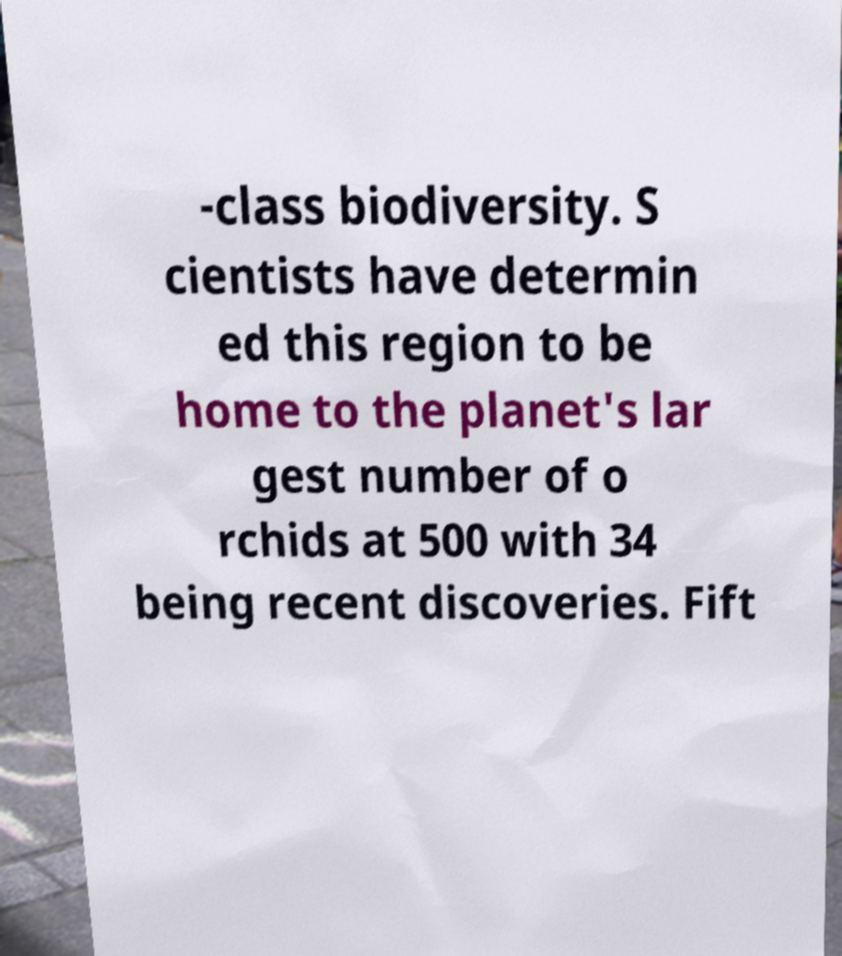What messages or text are displayed in this image? I need them in a readable, typed format. -class biodiversity. S cientists have determin ed this region to be home to the planet's lar gest number of o rchids at 500 with 34 being recent discoveries. Fift 